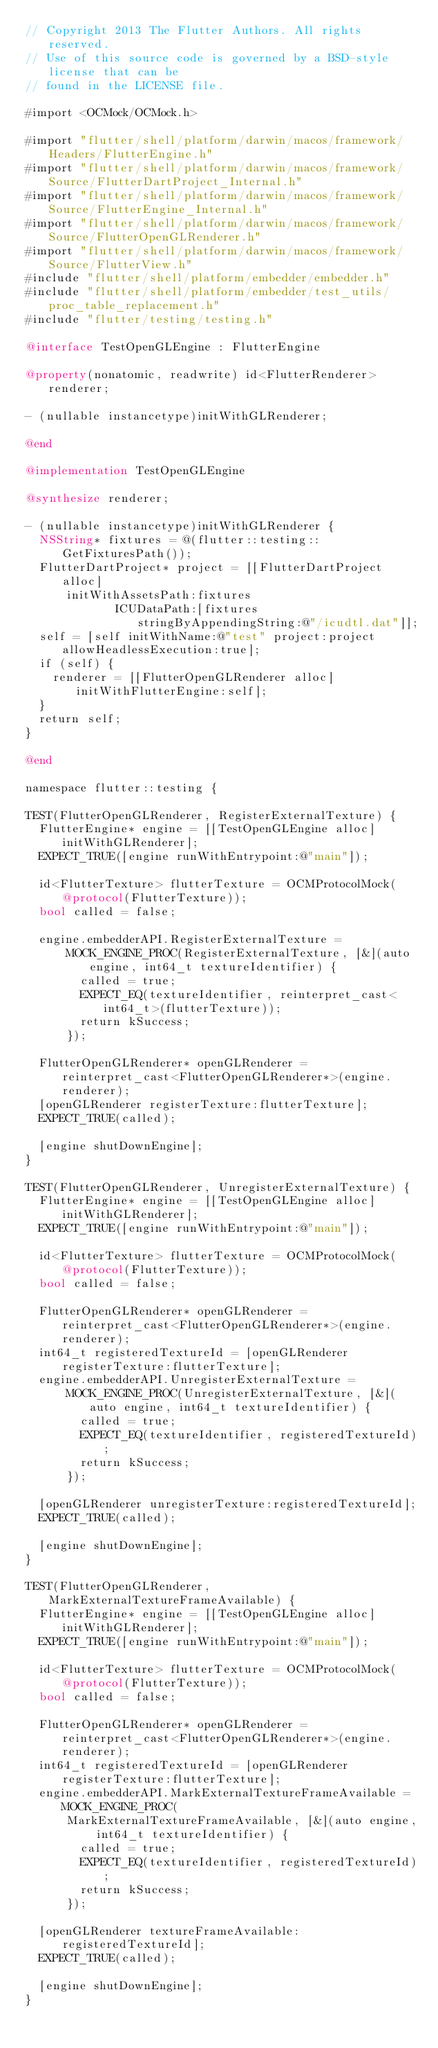<code> <loc_0><loc_0><loc_500><loc_500><_ObjectiveC_>// Copyright 2013 The Flutter Authors. All rights reserved.
// Use of this source code is governed by a BSD-style license that can be
// found in the LICENSE file.

#import <OCMock/OCMock.h>

#import "flutter/shell/platform/darwin/macos/framework/Headers/FlutterEngine.h"
#import "flutter/shell/platform/darwin/macos/framework/Source/FlutterDartProject_Internal.h"
#import "flutter/shell/platform/darwin/macos/framework/Source/FlutterEngine_Internal.h"
#import "flutter/shell/platform/darwin/macos/framework/Source/FlutterOpenGLRenderer.h"
#import "flutter/shell/platform/darwin/macos/framework/Source/FlutterView.h"
#include "flutter/shell/platform/embedder/embedder.h"
#include "flutter/shell/platform/embedder/test_utils/proc_table_replacement.h"
#include "flutter/testing/testing.h"

@interface TestOpenGLEngine : FlutterEngine

@property(nonatomic, readwrite) id<FlutterRenderer> renderer;

- (nullable instancetype)initWithGLRenderer;

@end

@implementation TestOpenGLEngine

@synthesize renderer;

- (nullable instancetype)initWithGLRenderer {
  NSString* fixtures = @(flutter::testing::GetFixturesPath());
  FlutterDartProject* project = [[FlutterDartProject alloc]
      initWithAssetsPath:fixtures
             ICUDataPath:[fixtures stringByAppendingString:@"/icudtl.dat"]];
  self = [self initWithName:@"test" project:project allowHeadlessExecution:true];
  if (self) {
    renderer = [[FlutterOpenGLRenderer alloc] initWithFlutterEngine:self];
  }
  return self;
}

@end

namespace flutter::testing {

TEST(FlutterOpenGLRenderer, RegisterExternalTexture) {
  FlutterEngine* engine = [[TestOpenGLEngine alloc] initWithGLRenderer];
  EXPECT_TRUE([engine runWithEntrypoint:@"main"]);

  id<FlutterTexture> flutterTexture = OCMProtocolMock(@protocol(FlutterTexture));
  bool called = false;

  engine.embedderAPI.RegisterExternalTexture =
      MOCK_ENGINE_PROC(RegisterExternalTexture, [&](auto engine, int64_t textureIdentifier) {
        called = true;
        EXPECT_EQ(textureIdentifier, reinterpret_cast<int64_t>(flutterTexture));
        return kSuccess;
      });

  FlutterOpenGLRenderer* openGLRenderer = reinterpret_cast<FlutterOpenGLRenderer*>(engine.renderer);
  [openGLRenderer registerTexture:flutterTexture];
  EXPECT_TRUE(called);

  [engine shutDownEngine];
}

TEST(FlutterOpenGLRenderer, UnregisterExternalTexture) {
  FlutterEngine* engine = [[TestOpenGLEngine alloc] initWithGLRenderer];
  EXPECT_TRUE([engine runWithEntrypoint:@"main"]);

  id<FlutterTexture> flutterTexture = OCMProtocolMock(@protocol(FlutterTexture));
  bool called = false;

  FlutterOpenGLRenderer* openGLRenderer = reinterpret_cast<FlutterOpenGLRenderer*>(engine.renderer);
  int64_t registeredTextureId = [openGLRenderer registerTexture:flutterTexture];
  engine.embedderAPI.UnregisterExternalTexture =
      MOCK_ENGINE_PROC(UnregisterExternalTexture, [&](auto engine, int64_t textureIdentifier) {
        called = true;
        EXPECT_EQ(textureIdentifier, registeredTextureId);
        return kSuccess;
      });

  [openGLRenderer unregisterTexture:registeredTextureId];
  EXPECT_TRUE(called);

  [engine shutDownEngine];
}

TEST(FlutterOpenGLRenderer, MarkExternalTextureFrameAvailable) {
  FlutterEngine* engine = [[TestOpenGLEngine alloc] initWithGLRenderer];
  EXPECT_TRUE([engine runWithEntrypoint:@"main"]);

  id<FlutterTexture> flutterTexture = OCMProtocolMock(@protocol(FlutterTexture));
  bool called = false;

  FlutterOpenGLRenderer* openGLRenderer = reinterpret_cast<FlutterOpenGLRenderer*>(engine.renderer);
  int64_t registeredTextureId = [openGLRenderer registerTexture:flutterTexture];
  engine.embedderAPI.MarkExternalTextureFrameAvailable = MOCK_ENGINE_PROC(
      MarkExternalTextureFrameAvailable, [&](auto engine, int64_t textureIdentifier) {
        called = true;
        EXPECT_EQ(textureIdentifier, registeredTextureId);
        return kSuccess;
      });

  [openGLRenderer textureFrameAvailable:registeredTextureId];
  EXPECT_TRUE(called);

  [engine shutDownEngine];
}
</code> 